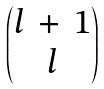<formula> <loc_0><loc_0><loc_500><loc_500>\begin{pmatrix} l \, + \, 1 \\ l \end{pmatrix}</formula> 